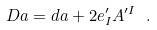<formula> <loc_0><loc_0><loc_500><loc_500>D a = d a + 2 e _ { I } ^ { \prime } A ^ { \prime I } \ .</formula> 